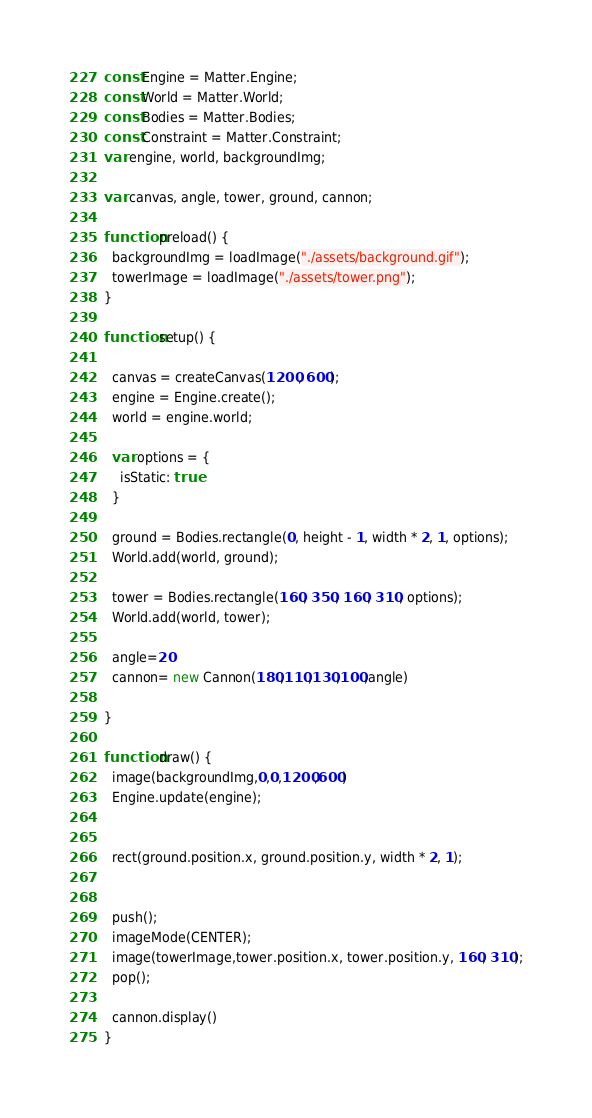<code> <loc_0><loc_0><loc_500><loc_500><_JavaScript_>const Engine = Matter.Engine;
const World = Matter.World;
const Bodies = Matter.Bodies;
const Constraint = Matter.Constraint;
var engine, world, backgroundImg;

var canvas, angle, tower, ground, cannon;

function preload() {
  backgroundImg = loadImage("./assets/background.gif");
  towerImage = loadImage("./assets/tower.png");
}

function setup() {

  canvas = createCanvas(1200, 600);
  engine = Engine.create();
  world = engine.world;
  
  var options = {
    isStatic: true
  }

  ground = Bodies.rectangle(0, height - 1, width * 2, 1, options);
  World.add(world, ground);

  tower = Bodies.rectangle(160, 350, 160, 310, options);
  World.add(world, tower);

  angle=20
  cannon= new Cannon(180,110,130,100,angle)

}

function draw() {
  image(backgroundImg,0,0,1200,600)
  Engine.update(engine);

  
  rect(ground.position.x, ground.position.y, width * 2, 1);
  

  push();
  imageMode(CENTER);
  image(towerImage,tower.position.x, tower.position.y, 160, 310);
  pop();  

  cannon.display()
}
</code> 